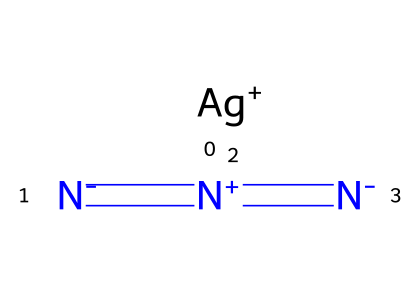What is the total number of atoms in silver azide? The structural formula consists of one silver atom (Ag), three nitrogen atoms (N). Therefore, adding them together results in a total of four atoms.
Answer: four How many nitrogen atoms are present in silver azide? The structure of silver azide clearly shows three nitrogen atoms are bonded together, as indicated by the three N symbols in the formula.
Answer: three What type of bond exists between the nitrogen atoms in silver azide? The nitrogen atoms are connected by double bonds, as indicated by the '=' signs in the SMILES representation, which indicates that each pair of nitrogen atoms is linked by a double bond.
Answer: double bonds Which atom in silver azide gives it its silver color? The silver color of the substance is provided by the silver atom (Ag) in its chemical structure, as it is the only metal present.
Answer: silver What is the overall charge of silver azide? The charge on the silver atom is +1, while the three nitrogen atoms collectively carry a -1 charge (since they form an azide group). Therefore, the overall charge of the molecule balances to 0.
Answer: neutral What type of chemical is silver azide classified as? Silver azide falls under the classification of azides based on its structure, characterized by the presence of the azide functional group (-N3).
Answer: azide Why is silver azide used in automotive safety devices? Silver azide is favored in automotive safety devices due to its sensitivity and ability to decompose rapidly, providing a quick release of gas during activation, which is beneficial in safety applications.
Answer: sensitivity 